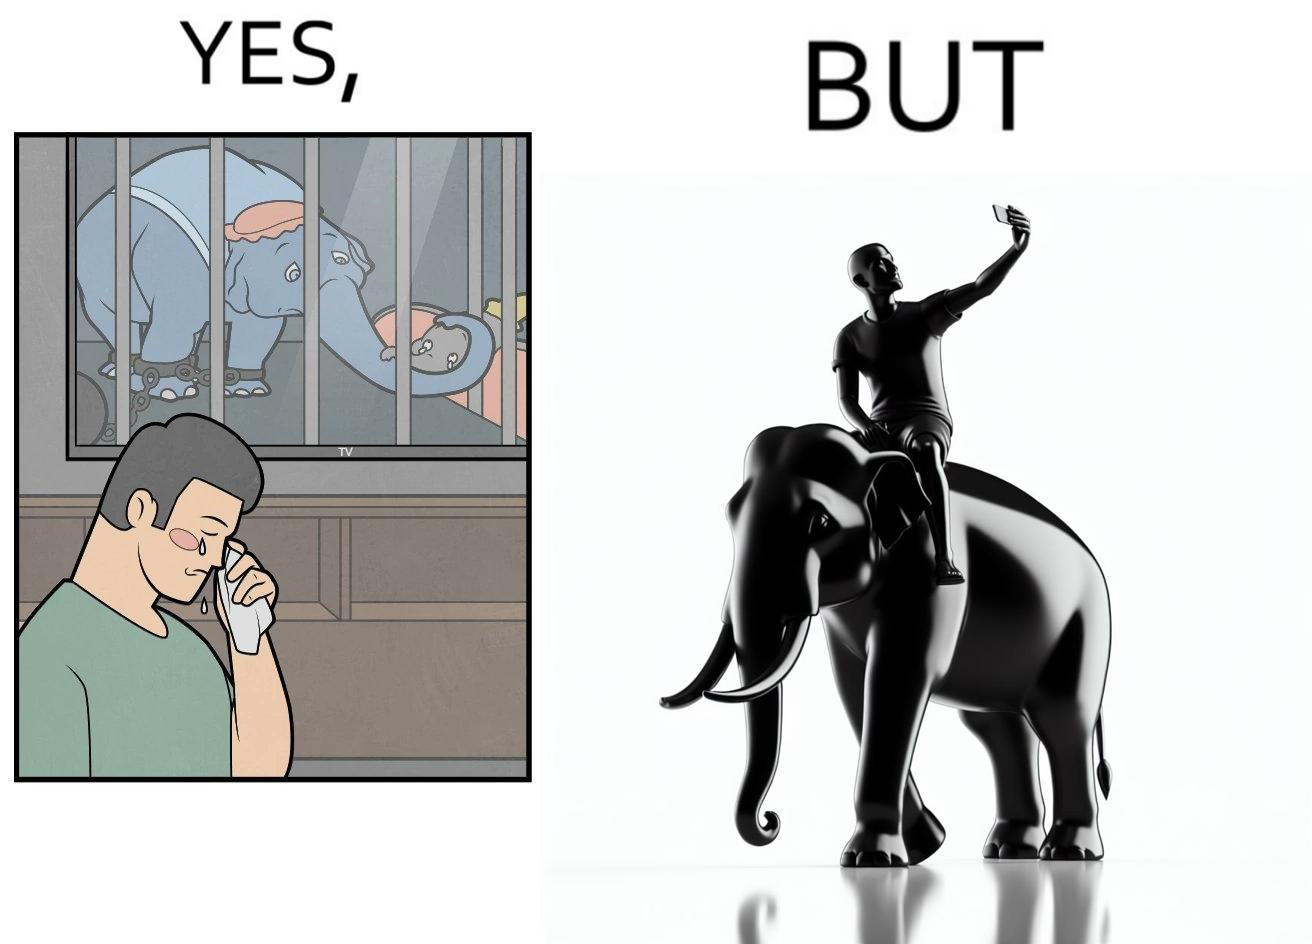What is shown in this image? The image is ironic, because the people who get sentimental over imprisoned animal while watching TV shows often feel okay when using animals for labor 